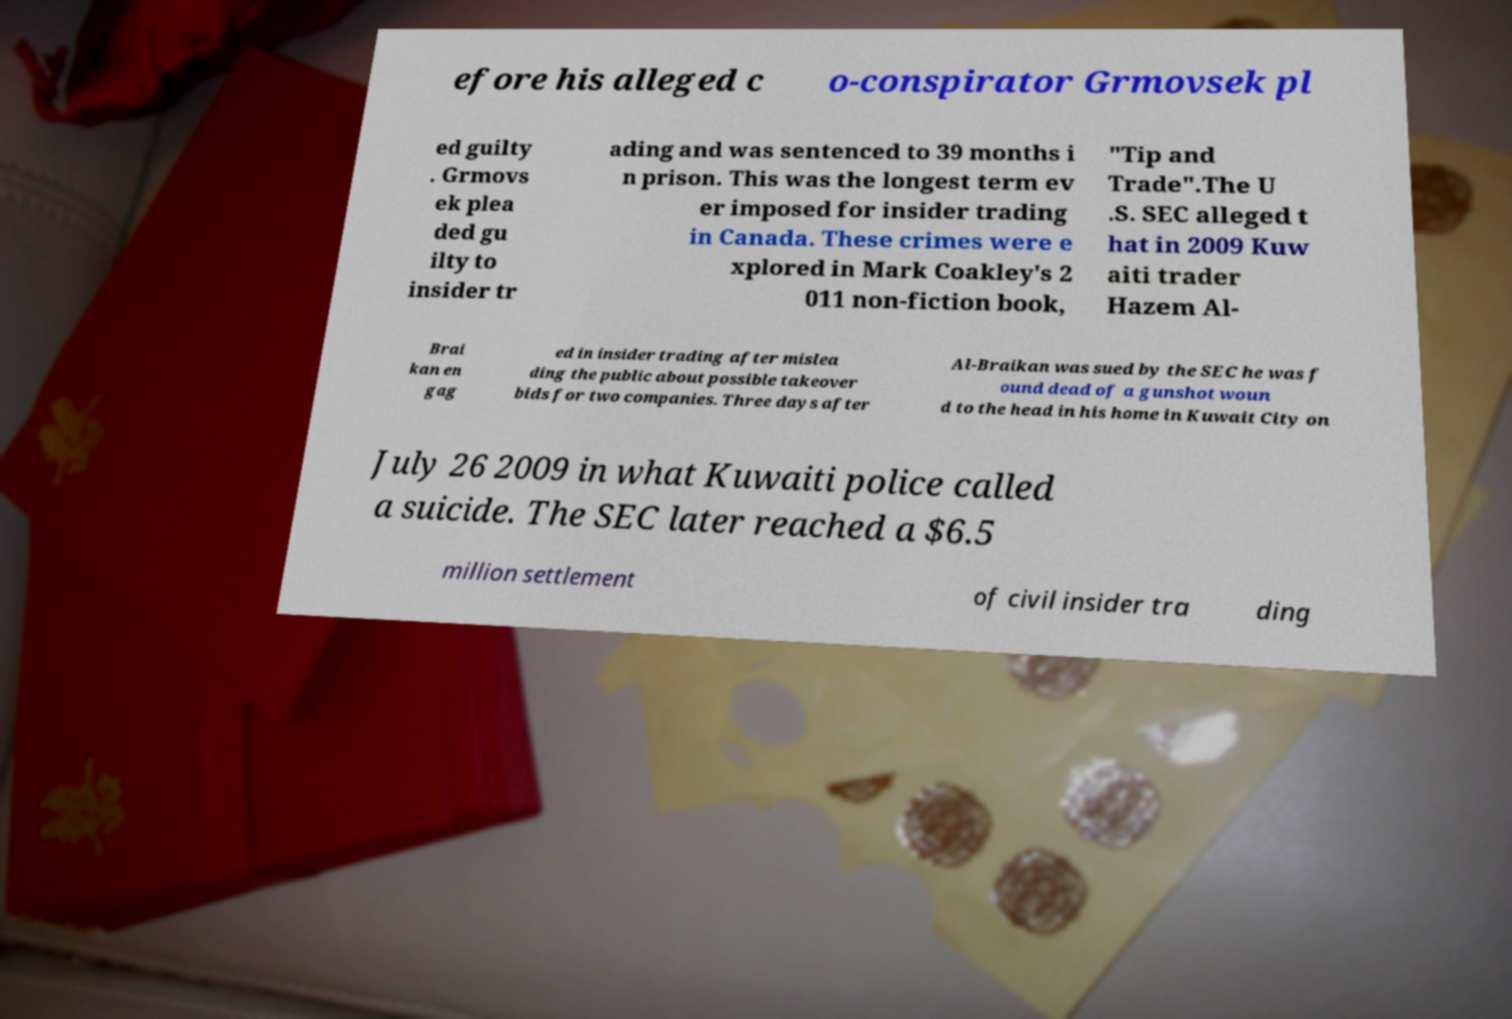Please read and relay the text visible in this image. What does it say? efore his alleged c o-conspirator Grmovsek pl ed guilty . Grmovs ek plea ded gu ilty to insider tr ading and was sentenced to 39 months i n prison. This was the longest term ev er imposed for insider trading in Canada. These crimes were e xplored in Mark Coakley's 2 011 non-fiction book, "Tip and Trade".The U .S. SEC alleged t hat in 2009 Kuw aiti trader Hazem Al- Brai kan en gag ed in insider trading after mislea ding the public about possible takeover bids for two companies. Three days after Al-Braikan was sued by the SEC he was f ound dead of a gunshot woun d to the head in his home in Kuwait City on July 26 2009 in what Kuwaiti police called a suicide. The SEC later reached a $6.5 million settlement of civil insider tra ding 